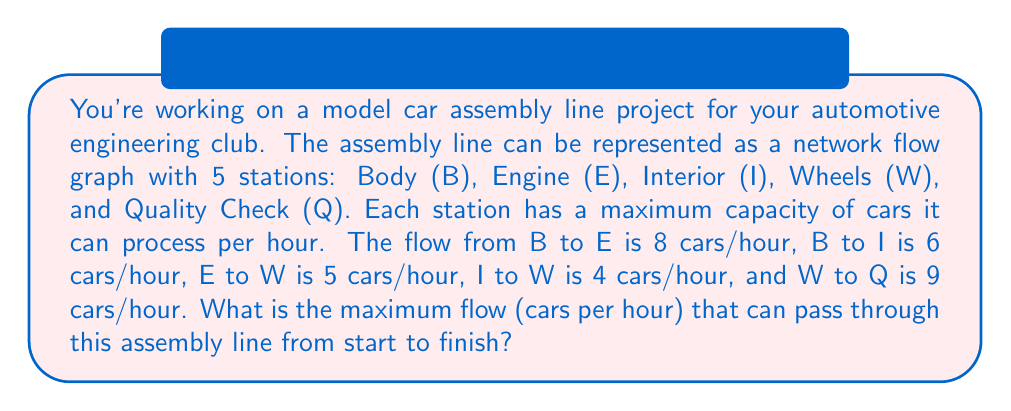Can you solve this math problem? To solve this problem, we need to use the concept of maximum flow in a network. The maximum flow is determined by the minimum cut in the network, which is the bottleneck of the system.

Let's analyze the flow through each path:

1. Path 1: B → E → W → Q
   Minimum flow in this path: $\min(8, 5, 9) = 5$ cars/hour

2. Path 2: B → I → W → Q
   Minimum flow in this path: $\min(6, 4, 9) = 4$ cars/hour

The total maximum flow is the sum of the flows through all paths:

$\text{Maximum Flow} = \text{Flow(Path 1)} + \text{Flow(Path 2)}$

$\text{Maximum Flow} = 5 + 4 = 9$ cars/hour

We can verify that this doesn't exceed the capacity of the final stage (Q), which is 9 cars/hour.

In graph theory, this result is consistent with the Max-Flow Min-Cut Theorem, which states that the maximum flow in a network is equal to the capacity of the minimum cut. In this case, the minimum cut occurs at the W → Q stage, which has a capacity of 9 cars/hour.
Answer: The maximum flow through the model car assembly line is 9 cars per hour. 